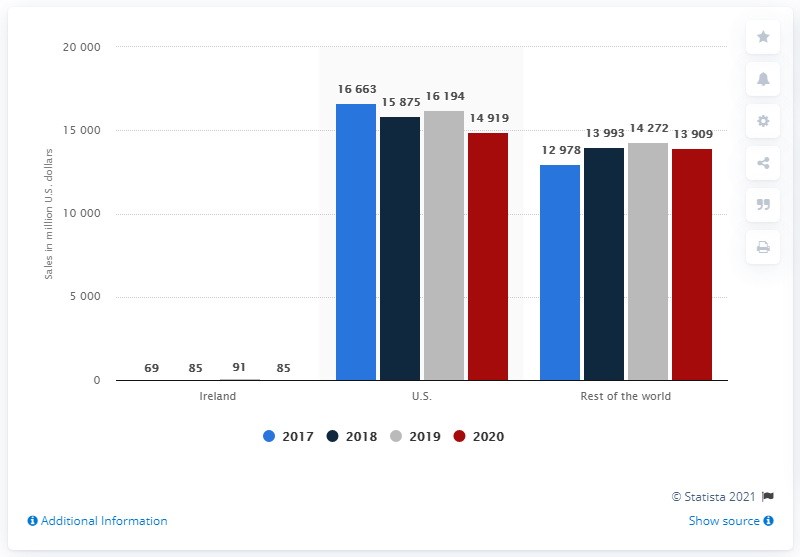Highlight a few significant elements in this photo. In 2020, the revenue generated by Ireland in the United States was approximately 85 million. In 2017, the highest revenue difference was 2,754, and in 2020, the lowest value was 2,754. The year mentioned in red in the chart is 2020. 